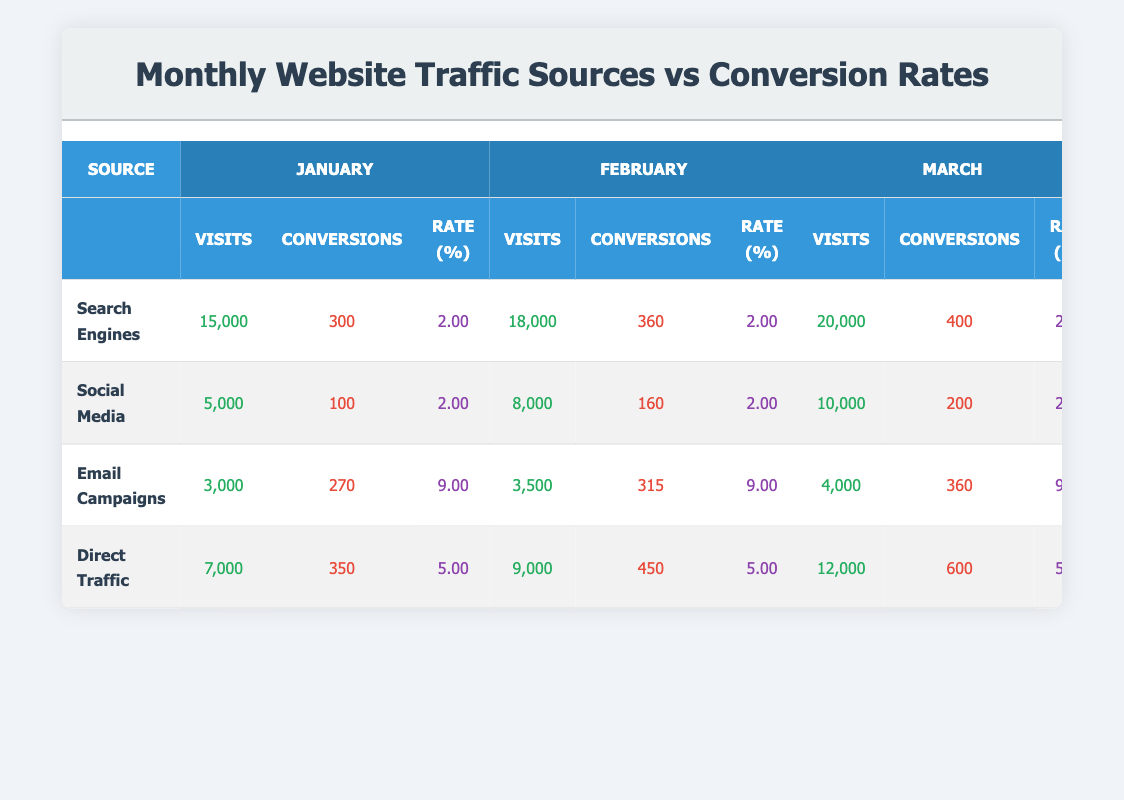What is the conversion rate for Email Campaigns in March? The table shows that for Email Campaigns in March, the conversion rate is listed under the "Rate (%)" column for that month. Looking at the relevant section, the conversion rate for March is 9.00.
Answer: 9.00 How many visits did Social Media generate in February? Referring to the "Visits" column under the Social Media row for February, it shows that Social Media generated 8,000 visits that month.
Answer: 8,000 Which traffic source had the highest conversion rate across all three months? To determine the highest conversion rate, we compare the conversion rates for each source: Email Campaigns at 9.00, Direct Traffic at 5.00, and both Search Engines and Social Media at 2.00. Email Campaigns consistently has the highest conversion rate of 9.00.
Answer: Email Campaigns What is the total number of visits from Direct Traffic over the three months? To find the total visits from Direct Traffic, we sum the visits for each month: 7,000 (January) + 9,000 (February) + 12,000 (March) equals 28,000.
Answer: 28,000 Did Search Engines have a higher number of conversions than Direct Traffic in January? Comparing the "Conversions" for both sources in January, Search Engines had 300 conversions and Direct Traffic had 350 conversions. Since 350 is greater than 300, the statement is false.
Answer: No How does the conversion rate of Social Media compare to that of Search Engines for all months? Reviewing the conversion rates for Social Media and Search Engines: both have 2.00 for January, February, and March. Therefore, their conversion rates are the same across all months.
Answer: They are the same What is the average number of visits recorded for Email Campaigns over the three months? The visits for Email Campaigns over three months are 3,000 (January), 3,500 (February), and 4,000 (March). Adding these gives 10,500, and dividing by 3 (number of months) results in an average of 3,500.
Answer: 3,500 Which traffic source saw the largest increase in conversions from January to March? To find the largest increase, we calculate the conversions for each source: Search Engines (300 to 400), Social Media (100 to 200), Email Campaigns (270 to 360), and Direct Traffic (350 to 600). The largest increase is 250 for Direct Traffic (600 - 350 = 250).
Answer: Direct Traffic How many total conversions were made from Email Campaigns in February and March combined? Summing the conversions for Email Campaigns: 315 (February) + 360 (March) gives a total of 675 conversions in those months.
Answer: 675 